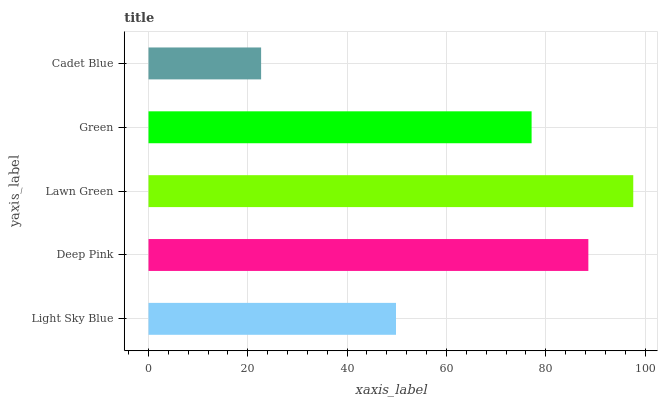Is Cadet Blue the minimum?
Answer yes or no. Yes. Is Lawn Green the maximum?
Answer yes or no. Yes. Is Deep Pink the minimum?
Answer yes or no. No. Is Deep Pink the maximum?
Answer yes or no. No. Is Deep Pink greater than Light Sky Blue?
Answer yes or no. Yes. Is Light Sky Blue less than Deep Pink?
Answer yes or no. Yes. Is Light Sky Blue greater than Deep Pink?
Answer yes or no. No. Is Deep Pink less than Light Sky Blue?
Answer yes or no. No. Is Green the high median?
Answer yes or no. Yes. Is Green the low median?
Answer yes or no. Yes. Is Lawn Green the high median?
Answer yes or no. No. Is Light Sky Blue the low median?
Answer yes or no. No. 